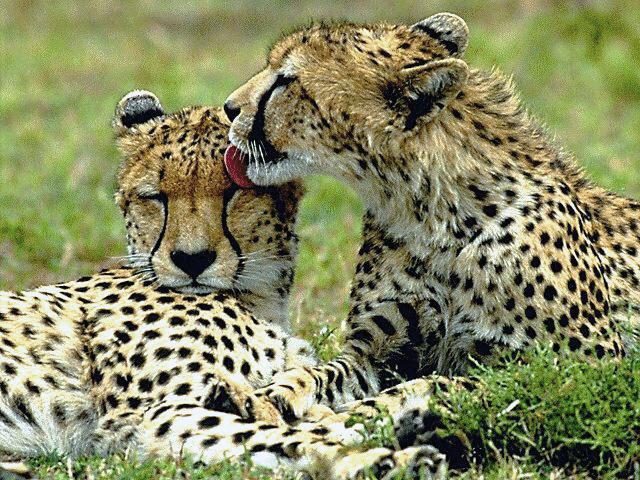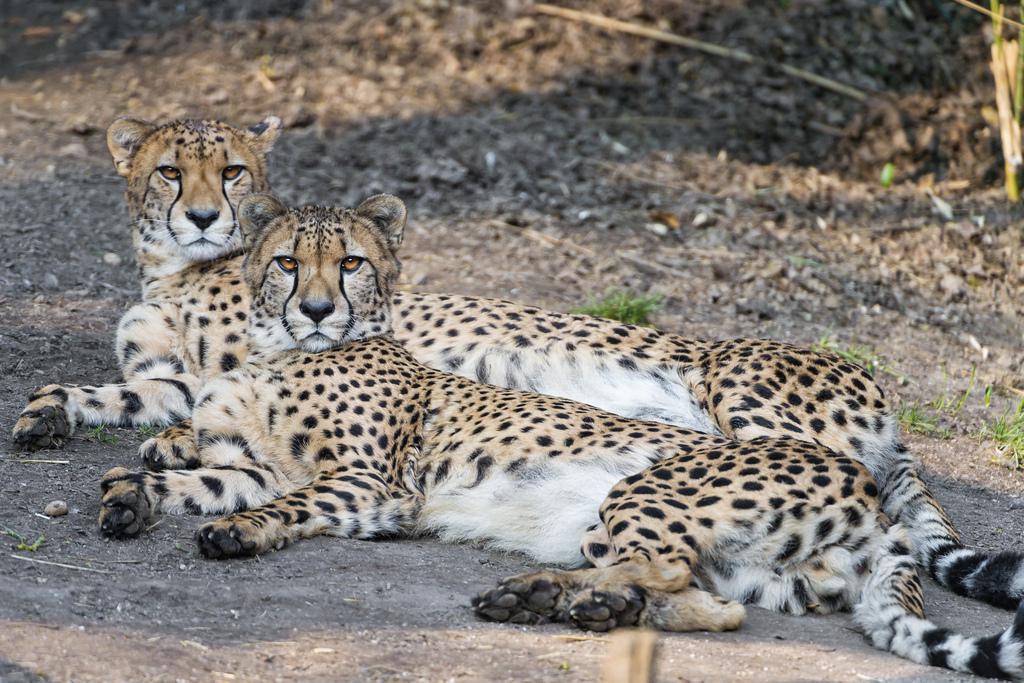The first image is the image on the left, the second image is the image on the right. Considering the images on both sides, is "There are a pair of cheetahs laying on the grown while one is grooming the other." valid? Answer yes or no. Yes. The first image is the image on the left, the second image is the image on the right. Analyze the images presented: Is the assertion "All of the cheetahs are laying down." valid? Answer yes or no. Yes. 